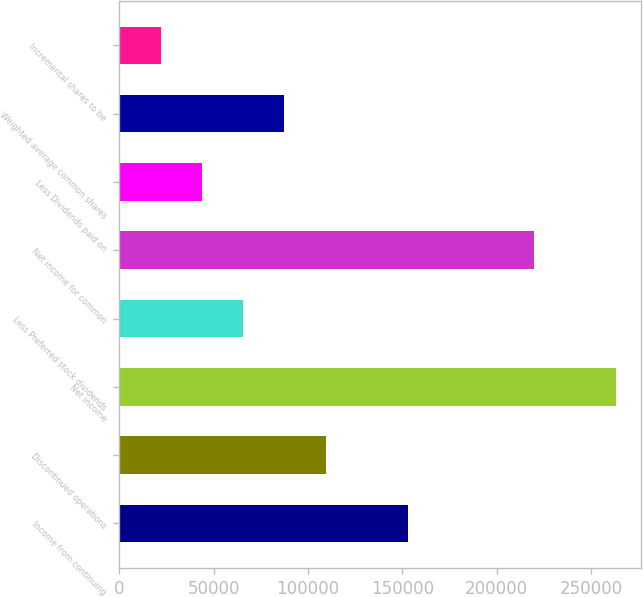Convert chart to OTSL. <chart><loc_0><loc_0><loc_500><loc_500><bar_chart><fcel>Income from continuing<fcel>Discontinued operations<fcel>Net income<fcel>Less Preferred stock dividends<fcel>Net income for common<fcel>Less Dividends paid on<fcel>Weighted average common shares<fcel>Incremental shares to be<nl><fcel>152959<fcel>109257<fcel>263410<fcel>65555.3<fcel>219709<fcel>43704.5<fcel>87406.1<fcel>21853.7<nl></chart> 